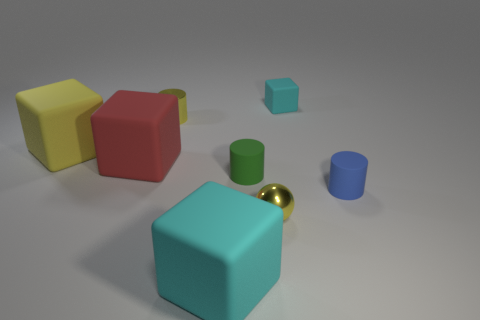How many big matte things are on the right side of the large yellow matte block?
Provide a short and direct response. 2. Is the number of tiny yellow cylinders in front of the large red block less than the number of rubber cubes that are behind the yellow sphere?
Provide a succinct answer. Yes. The small cyan object behind the tiny yellow object in front of the tiny cylinder to the right of the tiny cyan matte cube is what shape?
Ensure brevity in your answer.  Cube. What shape is the object that is behind the red thing and to the right of the big cyan rubber object?
Your answer should be compact. Cube. Are there any blue objects that have the same material as the red cube?
Provide a short and direct response. Yes. There is a object that is the same color as the tiny cube; what size is it?
Provide a short and direct response. Large. There is a big matte cube in front of the big red cube; what is its color?
Provide a succinct answer. Cyan. There is a red thing; is its shape the same as the tiny yellow metallic object in front of the tiny green cylinder?
Ensure brevity in your answer.  No. Is there a big matte cube that has the same color as the small cube?
Offer a very short reply. Yes. There is a yellow block that is the same material as the blue cylinder; what is its size?
Provide a short and direct response. Large. 